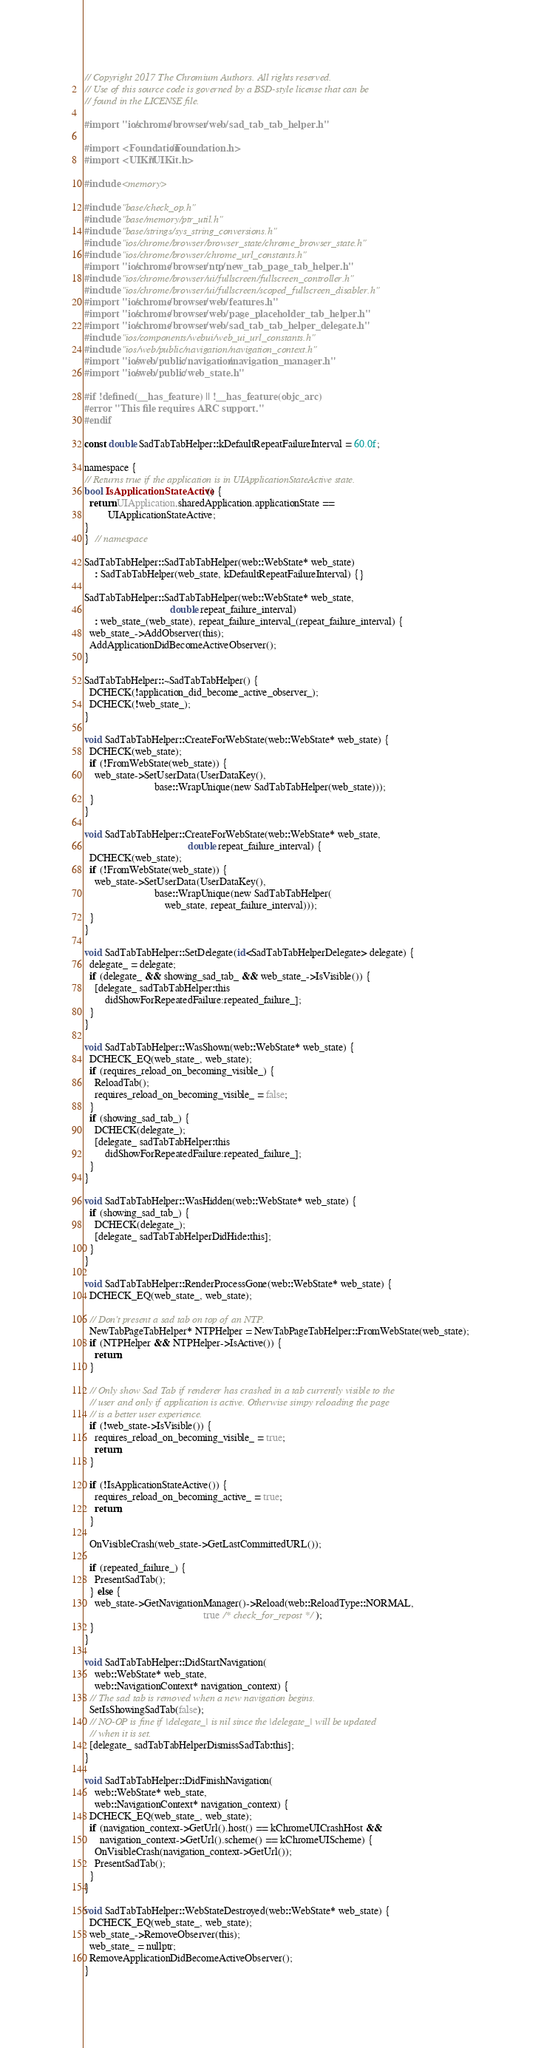<code> <loc_0><loc_0><loc_500><loc_500><_ObjectiveC_>// Copyright 2017 The Chromium Authors. All rights reserved.
// Use of this source code is governed by a BSD-style license that can be
// found in the LICENSE file.

#import "ios/chrome/browser/web/sad_tab_tab_helper.h"

#import <Foundation/Foundation.h>
#import <UIKit/UIKit.h>

#include <memory>

#include "base/check_op.h"
#include "base/memory/ptr_util.h"
#include "base/strings/sys_string_conversions.h"
#include "ios/chrome/browser/browser_state/chrome_browser_state.h"
#include "ios/chrome/browser/chrome_url_constants.h"
#import "ios/chrome/browser/ntp/new_tab_page_tab_helper.h"
#include "ios/chrome/browser/ui/fullscreen/fullscreen_controller.h"
#include "ios/chrome/browser/ui/fullscreen/scoped_fullscreen_disabler.h"
#import "ios/chrome/browser/web/features.h"
#import "ios/chrome/browser/web/page_placeholder_tab_helper.h"
#import "ios/chrome/browser/web/sad_tab_tab_helper_delegate.h"
#include "ios/components/webui/web_ui_url_constants.h"
#include "ios/web/public/navigation/navigation_context.h"
#import "ios/web/public/navigation/navigation_manager.h"
#import "ios/web/public/web_state.h"

#if !defined(__has_feature) || !__has_feature(objc_arc)
#error "This file requires ARC support."
#endif

const double SadTabTabHelper::kDefaultRepeatFailureInterval = 60.0f;

namespace {
// Returns true if the application is in UIApplicationStateActive state.
bool IsApplicationStateActive() {
  return UIApplication.sharedApplication.applicationState ==
         UIApplicationStateActive;
}
}  // namespace

SadTabTabHelper::SadTabTabHelper(web::WebState* web_state)
    : SadTabTabHelper(web_state, kDefaultRepeatFailureInterval) {}

SadTabTabHelper::SadTabTabHelper(web::WebState* web_state,
                                 double repeat_failure_interval)
    : web_state_(web_state), repeat_failure_interval_(repeat_failure_interval) {
  web_state_->AddObserver(this);
  AddApplicationDidBecomeActiveObserver();
}

SadTabTabHelper::~SadTabTabHelper() {
  DCHECK(!application_did_become_active_observer_);
  DCHECK(!web_state_);
}

void SadTabTabHelper::CreateForWebState(web::WebState* web_state) {
  DCHECK(web_state);
  if (!FromWebState(web_state)) {
    web_state->SetUserData(UserDataKey(),
                           base::WrapUnique(new SadTabTabHelper(web_state)));
  }
}

void SadTabTabHelper::CreateForWebState(web::WebState* web_state,
                                        double repeat_failure_interval) {
  DCHECK(web_state);
  if (!FromWebState(web_state)) {
    web_state->SetUserData(UserDataKey(),
                           base::WrapUnique(new SadTabTabHelper(
                               web_state, repeat_failure_interval)));
  }
}

void SadTabTabHelper::SetDelegate(id<SadTabTabHelperDelegate> delegate) {
  delegate_ = delegate;
  if (delegate_ && showing_sad_tab_ && web_state_->IsVisible()) {
    [delegate_ sadTabTabHelper:this
        didShowForRepeatedFailure:repeated_failure_];
  }
}

void SadTabTabHelper::WasShown(web::WebState* web_state) {
  DCHECK_EQ(web_state_, web_state);
  if (requires_reload_on_becoming_visible_) {
    ReloadTab();
    requires_reload_on_becoming_visible_ = false;
  }
  if (showing_sad_tab_) {
    DCHECK(delegate_);
    [delegate_ sadTabTabHelper:this
        didShowForRepeatedFailure:repeated_failure_];
  }
}

void SadTabTabHelper::WasHidden(web::WebState* web_state) {
  if (showing_sad_tab_) {
    DCHECK(delegate_);
    [delegate_ sadTabTabHelperDidHide:this];
  }
}

void SadTabTabHelper::RenderProcessGone(web::WebState* web_state) {
  DCHECK_EQ(web_state_, web_state);

  // Don't present a sad tab on top of an NTP.
  NewTabPageTabHelper* NTPHelper = NewTabPageTabHelper::FromWebState(web_state);
  if (NTPHelper && NTPHelper->IsActive()) {
    return;
  }

  // Only show Sad Tab if renderer has crashed in a tab currently visible to the
  // user and only if application is active. Otherwise simpy reloading the page
  // is a better user experience.
  if (!web_state->IsVisible()) {
    requires_reload_on_becoming_visible_ = true;
    return;
  }

  if (!IsApplicationStateActive()) {
    requires_reload_on_becoming_active_ = true;
    return;
  }

  OnVisibleCrash(web_state->GetLastCommittedURL());

  if (repeated_failure_) {
    PresentSadTab();
  } else {
    web_state->GetNavigationManager()->Reload(web::ReloadType::NORMAL,
                                              true /* check_for_repost */);
  }
}

void SadTabTabHelper::DidStartNavigation(
    web::WebState* web_state,
    web::NavigationContext* navigation_context) {
  // The sad tab is removed when a new navigation begins.
  SetIsShowingSadTab(false);
  // NO-OP is fine if |delegate_| is nil since the |delegate_| will be updated
  // when it is set.
  [delegate_ sadTabTabHelperDismissSadTab:this];
}

void SadTabTabHelper::DidFinishNavigation(
    web::WebState* web_state,
    web::NavigationContext* navigation_context) {
  DCHECK_EQ(web_state_, web_state);
  if (navigation_context->GetUrl().host() == kChromeUICrashHost &&
      navigation_context->GetUrl().scheme() == kChromeUIScheme) {
    OnVisibleCrash(navigation_context->GetUrl());
    PresentSadTab();
  }
}

void SadTabTabHelper::WebStateDestroyed(web::WebState* web_state) {
  DCHECK_EQ(web_state_, web_state);
  web_state_->RemoveObserver(this);
  web_state_ = nullptr;
  RemoveApplicationDidBecomeActiveObserver();
}
</code> 